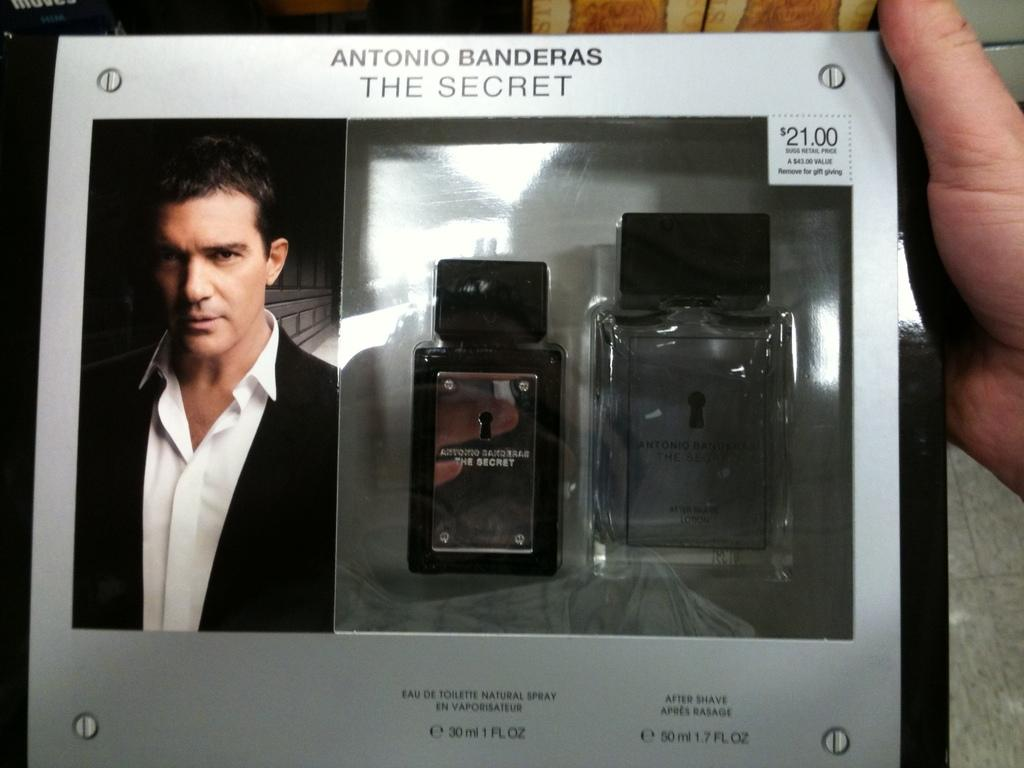What can be seen on the right side of the image? There is a hand and two lockers on the right side of the image. What is located in the foreground on the left side of the image? There is a person in the foreground on the left side of the image. What is written on the lockers? There is text written on the lockers. Can you describe the argument between the hand and the zephyr in the image? There is no argument or zephyr present in the image. What type of twig is being held by the person in the foreground? There is no twig visible in the image; the person is not holding anything. 